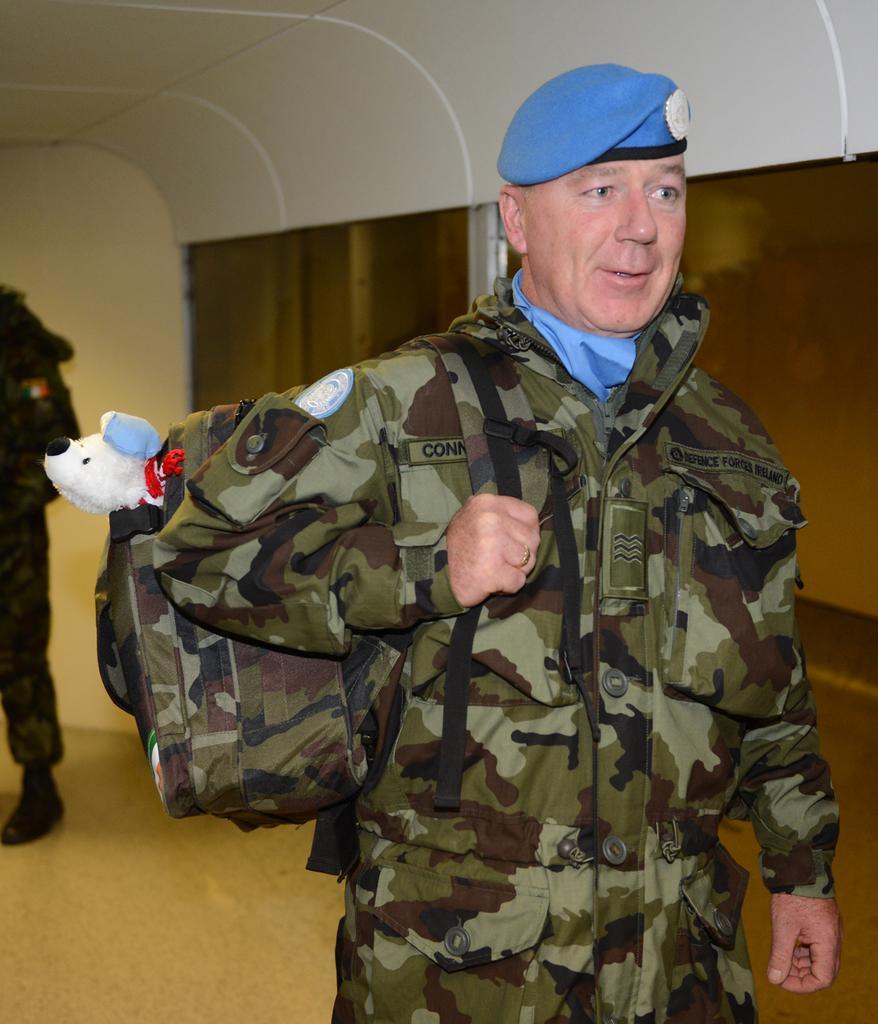Describe this image in one or two sentences. In this picture we can see a man who is standing on the floor. He is carrying his backpack. On the background there is a wall. Here we can see a one more person who is standing on the floor. 